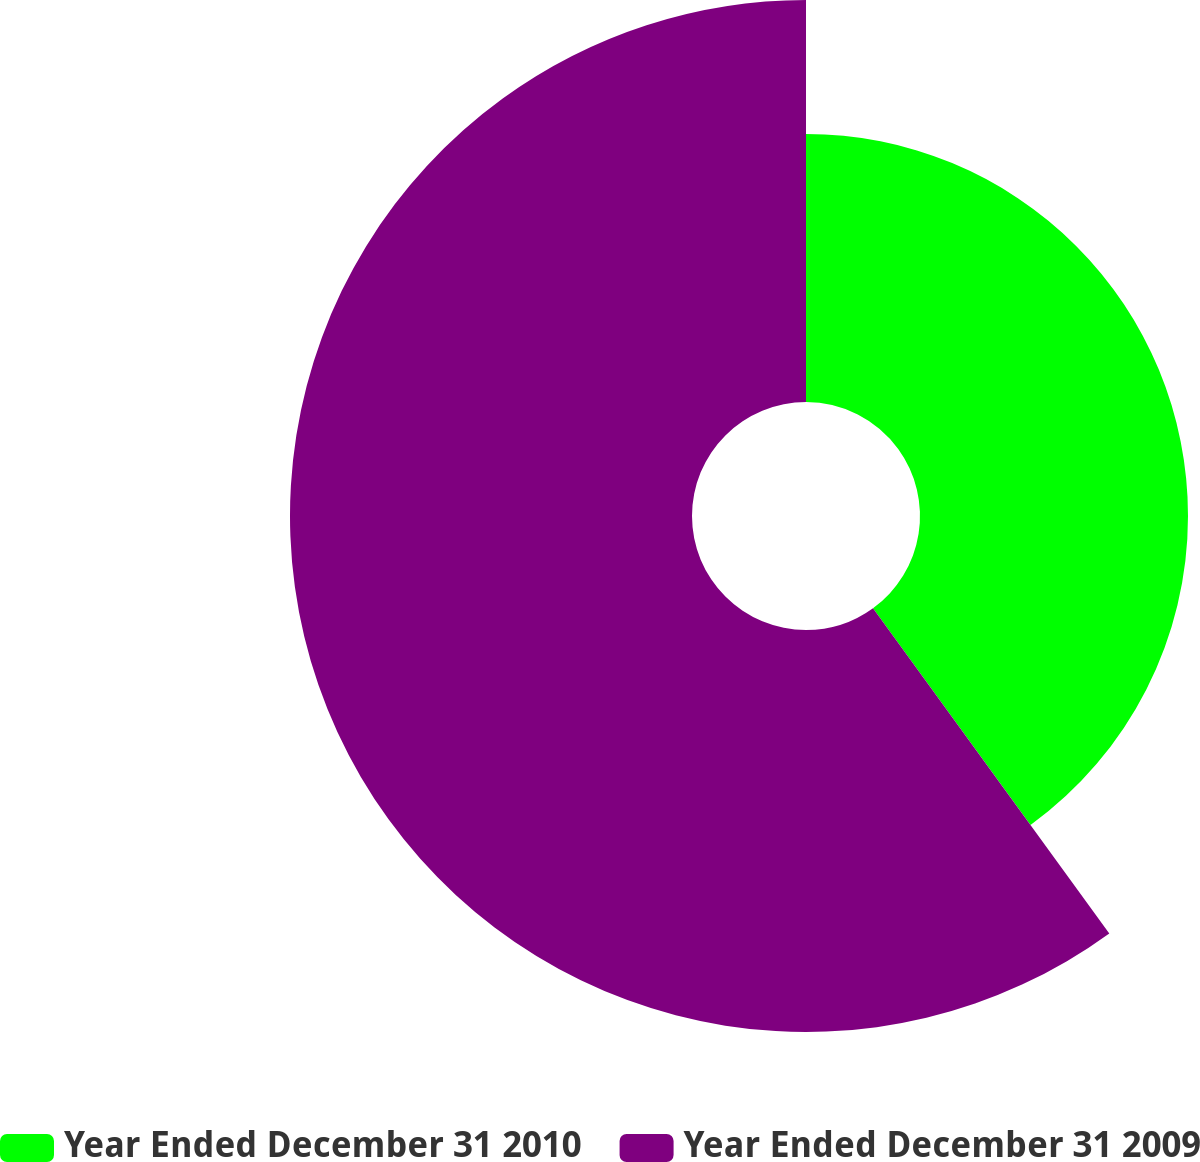<chart> <loc_0><loc_0><loc_500><loc_500><pie_chart><fcel>Year Ended December 31 2010<fcel>Year Ended December 31 2009<nl><fcel>40.0%<fcel>60.0%<nl></chart> 